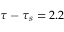<formula> <loc_0><loc_0><loc_500><loc_500>\tau - \tau _ { s } = 2 . 2</formula> 